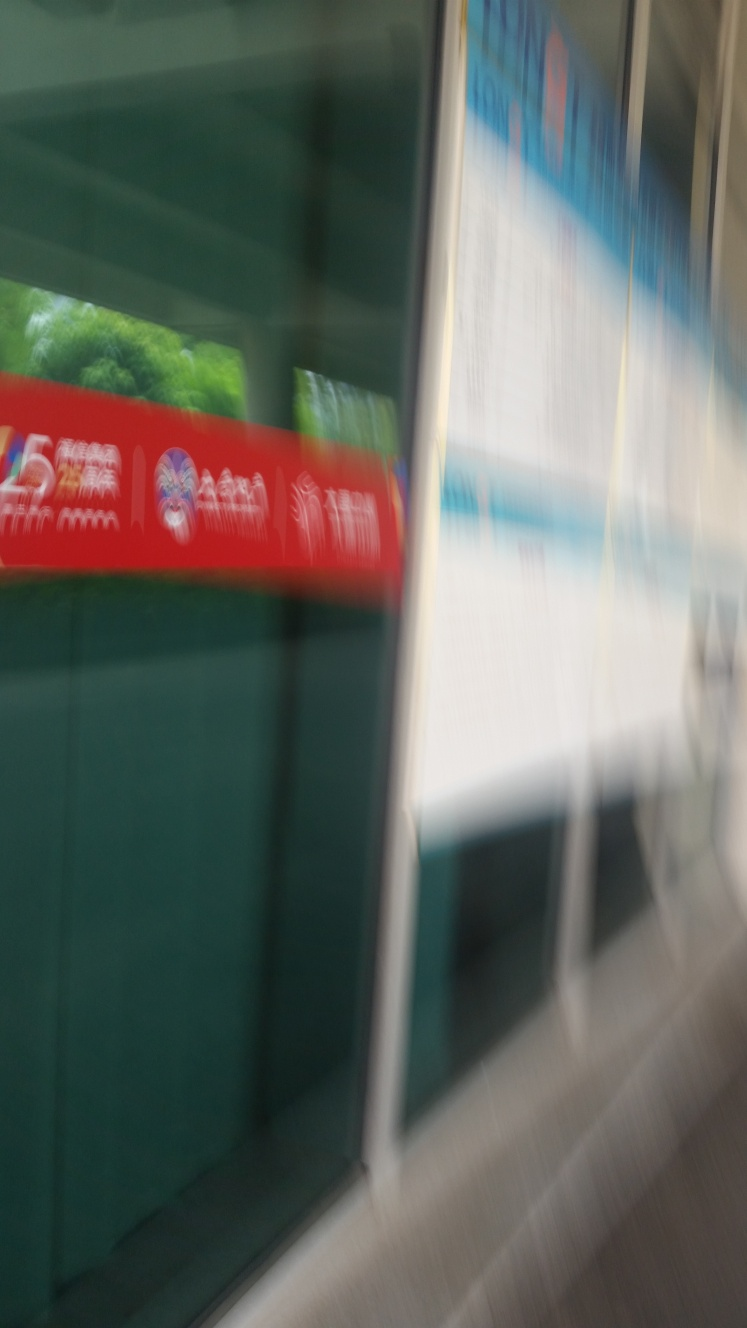Can you describe what elements can be identified despite the blur? Despite the motion blur, we can discern a contrast of colors including green, red, and white. There appears to be text and advertising on a wall or board, and the suggestion of a window reflecting trees which could imply the location is in or near a city with green spaces. What does this blurry image make you feel? The blurriness of the image conveys a sense of movement and haste, potentially echoing the fast-paced nature of urban life. It can evoke feelings of disorientation or the rush of traveling through a swiftly changing environment. 